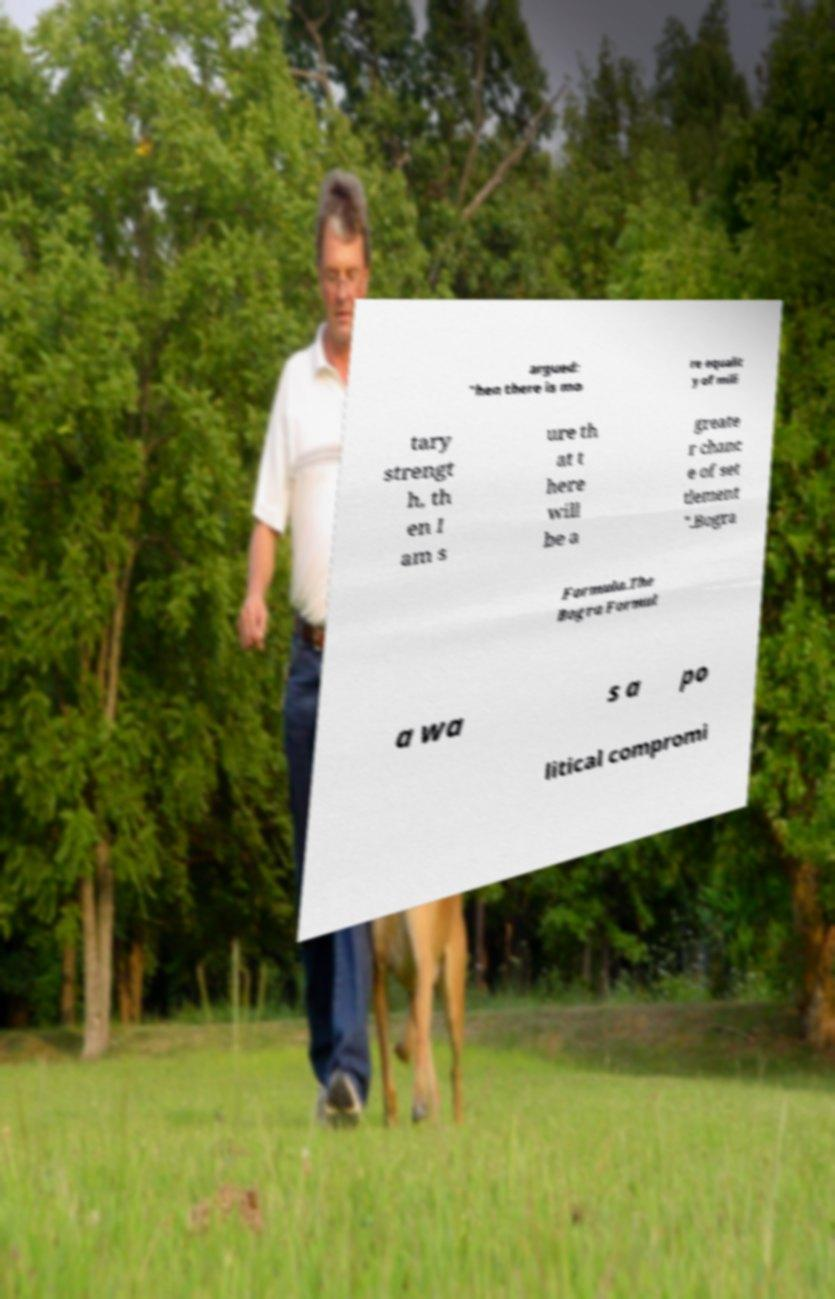Please read and relay the text visible in this image. What does it say? argued: "hen there is mo re equalit y of mili tary strengt h, th en I am s ure th at t here will be a greate r chanc e of set tlement ".Bogra Formula.The Bogra Formul a wa s a po litical compromi 